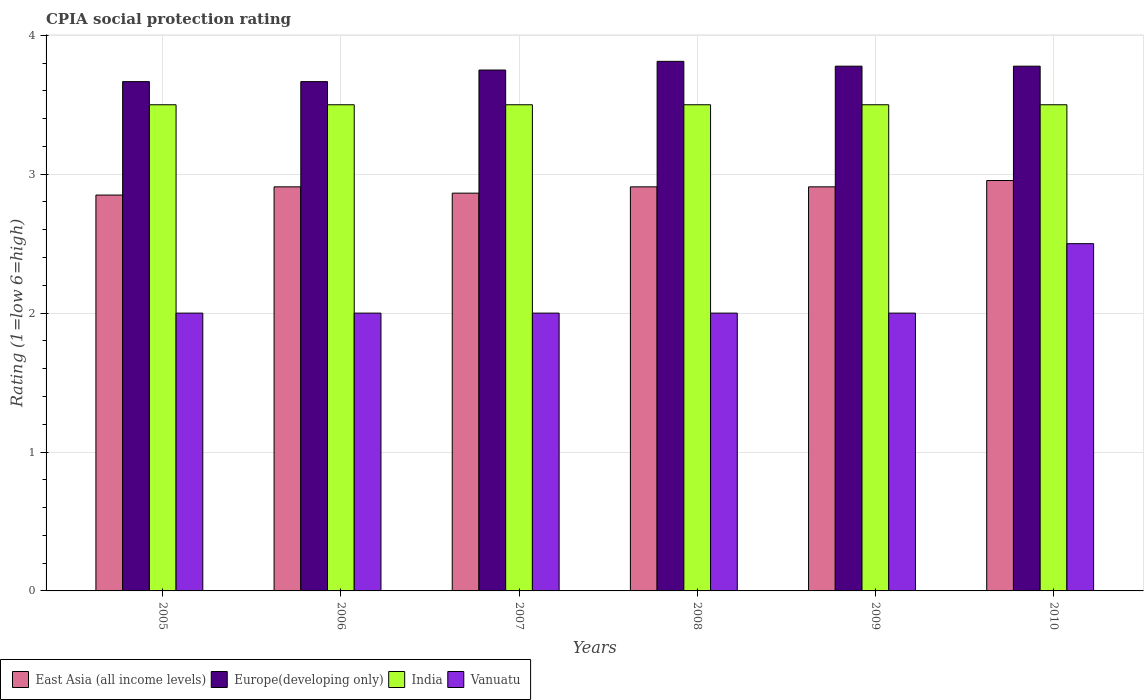How many different coloured bars are there?
Your response must be concise. 4. Are the number of bars per tick equal to the number of legend labels?
Offer a very short reply. Yes. How many bars are there on the 1st tick from the left?
Provide a short and direct response. 4. What is the label of the 2nd group of bars from the left?
Provide a succinct answer. 2006. In how many cases, is the number of bars for a given year not equal to the number of legend labels?
Give a very brief answer. 0. What is the CPIA rating in Vanuatu in 2005?
Provide a succinct answer. 2. Across all years, what is the maximum CPIA rating in East Asia (all income levels)?
Your answer should be compact. 2.95. What is the total CPIA rating in East Asia (all income levels) in the graph?
Offer a very short reply. 17.4. What is the difference between the CPIA rating in Europe(developing only) in 2008 and the CPIA rating in Vanuatu in 2010?
Your answer should be very brief. 1.31. What is the average CPIA rating in Europe(developing only) per year?
Your answer should be compact. 3.74. In the year 2008, what is the difference between the CPIA rating in India and CPIA rating in Europe(developing only)?
Offer a very short reply. -0.31. What is the ratio of the CPIA rating in East Asia (all income levels) in 2006 to that in 2008?
Offer a very short reply. 1. Is the CPIA rating in East Asia (all income levels) in 2006 less than that in 2009?
Your answer should be compact. No. Is the difference between the CPIA rating in India in 2006 and 2010 greater than the difference between the CPIA rating in Europe(developing only) in 2006 and 2010?
Keep it short and to the point. Yes. What is the difference between the highest and the second highest CPIA rating in East Asia (all income levels)?
Give a very brief answer. 0.05. What is the difference between the highest and the lowest CPIA rating in India?
Your answer should be compact. 0. What does the 2nd bar from the left in 2009 represents?
Offer a very short reply. Europe(developing only). What does the 4th bar from the right in 2007 represents?
Your response must be concise. East Asia (all income levels). Is it the case that in every year, the sum of the CPIA rating in Europe(developing only) and CPIA rating in East Asia (all income levels) is greater than the CPIA rating in India?
Give a very brief answer. Yes. How many years are there in the graph?
Ensure brevity in your answer.  6. Does the graph contain any zero values?
Give a very brief answer. No. Where does the legend appear in the graph?
Provide a short and direct response. Bottom left. How many legend labels are there?
Give a very brief answer. 4. What is the title of the graph?
Ensure brevity in your answer.  CPIA social protection rating. What is the label or title of the X-axis?
Provide a succinct answer. Years. What is the label or title of the Y-axis?
Give a very brief answer. Rating (1=low 6=high). What is the Rating (1=low 6=high) of East Asia (all income levels) in 2005?
Offer a very short reply. 2.85. What is the Rating (1=low 6=high) in Europe(developing only) in 2005?
Provide a succinct answer. 3.67. What is the Rating (1=low 6=high) of East Asia (all income levels) in 2006?
Make the answer very short. 2.91. What is the Rating (1=low 6=high) of Europe(developing only) in 2006?
Offer a terse response. 3.67. What is the Rating (1=low 6=high) in India in 2006?
Your answer should be compact. 3.5. What is the Rating (1=low 6=high) of Vanuatu in 2006?
Offer a terse response. 2. What is the Rating (1=low 6=high) of East Asia (all income levels) in 2007?
Ensure brevity in your answer.  2.86. What is the Rating (1=low 6=high) of Europe(developing only) in 2007?
Provide a short and direct response. 3.75. What is the Rating (1=low 6=high) in India in 2007?
Your response must be concise. 3.5. What is the Rating (1=low 6=high) in East Asia (all income levels) in 2008?
Offer a terse response. 2.91. What is the Rating (1=low 6=high) of Europe(developing only) in 2008?
Keep it short and to the point. 3.81. What is the Rating (1=low 6=high) in East Asia (all income levels) in 2009?
Offer a very short reply. 2.91. What is the Rating (1=low 6=high) of Europe(developing only) in 2009?
Keep it short and to the point. 3.78. What is the Rating (1=low 6=high) of Vanuatu in 2009?
Ensure brevity in your answer.  2. What is the Rating (1=low 6=high) of East Asia (all income levels) in 2010?
Provide a short and direct response. 2.95. What is the Rating (1=low 6=high) of Europe(developing only) in 2010?
Keep it short and to the point. 3.78. What is the Rating (1=low 6=high) of India in 2010?
Make the answer very short. 3.5. What is the Rating (1=low 6=high) in Vanuatu in 2010?
Your answer should be very brief. 2.5. Across all years, what is the maximum Rating (1=low 6=high) in East Asia (all income levels)?
Keep it short and to the point. 2.95. Across all years, what is the maximum Rating (1=low 6=high) of Europe(developing only)?
Make the answer very short. 3.81. Across all years, what is the minimum Rating (1=low 6=high) of East Asia (all income levels)?
Your response must be concise. 2.85. Across all years, what is the minimum Rating (1=low 6=high) in Europe(developing only)?
Ensure brevity in your answer.  3.67. What is the total Rating (1=low 6=high) of East Asia (all income levels) in the graph?
Offer a very short reply. 17.4. What is the total Rating (1=low 6=high) in Europe(developing only) in the graph?
Provide a succinct answer. 22.45. What is the total Rating (1=low 6=high) of Vanuatu in the graph?
Your answer should be very brief. 12.5. What is the difference between the Rating (1=low 6=high) in East Asia (all income levels) in 2005 and that in 2006?
Provide a succinct answer. -0.06. What is the difference between the Rating (1=low 6=high) in India in 2005 and that in 2006?
Your answer should be very brief. 0. What is the difference between the Rating (1=low 6=high) in Vanuatu in 2005 and that in 2006?
Ensure brevity in your answer.  0. What is the difference between the Rating (1=low 6=high) in East Asia (all income levels) in 2005 and that in 2007?
Offer a terse response. -0.01. What is the difference between the Rating (1=low 6=high) in Europe(developing only) in 2005 and that in 2007?
Your answer should be compact. -0.08. What is the difference between the Rating (1=low 6=high) in India in 2005 and that in 2007?
Give a very brief answer. 0. What is the difference between the Rating (1=low 6=high) in Vanuatu in 2005 and that in 2007?
Offer a very short reply. 0. What is the difference between the Rating (1=low 6=high) in East Asia (all income levels) in 2005 and that in 2008?
Provide a short and direct response. -0.06. What is the difference between the Rating (1=low 6=high) of Europe(developing only) in 2005 and that in 2008?
Your answer should be very brief. -0.15. What is the difference between the Rating (1=low 6=high) of India in 2005 and that in 2008?
Make the answer very short. 0. What is the difference between the Rating (1=low 6=high) of East Asia (all income levels) in 2005 and that in 2009?
Keep it short and to the point. -0.06. What is the difference between the Rating (1=low 6=high) of Europe(developing only) in 2005 and that in 2009?
Provide a succinct answer. -0.11. What is the difference between the Rating (1=low 6=high) of India in 2005 and that in 2009?
Your answer should be very brief. 0. What is the difference between the Rating (1=low 6=high) of Vanuatu in 2005 and that in 2009?
Your answer should be compact. 0. What is the difference between the Rating (1=low 6=high) of East Asia (all income levels) in 2005 and that in 2010?
Ensure brevity in your answer.  -0.1. What is the difference between the Rating (1=low 6=high) in Europe(developing only) in 2005 and that in 2010?
Make the answer very short. -0.11. What is the difference between the Rating (1=low 6=high) of India in 2005 and that in 2010?
Your answer should be compact. 0. What is the difference between the Rating (1=low 6=high) in Vanuatu in 2005 and that in 2010?
Make the answer very short. -0.5. What is the difference between the Rating (1=low 6=high) in East Asia (all income levels) in 2006 and that in 2007?
Your answer should be very brief. 0.05. What is the difference between the Rating (1=low 6=high) of Europe(developing only) in 2006 and that in 2007?
Keep it short and to the point. -0.08. What is the difference between the Rating (1=low 6=high) of East Asia (all income levels) in 2006 and that in 2008?
Provide a short and direct response. 0. What is the difference between the Rating (1=low 6=high) of Europe(developing only) in 2006 and that in 2008?
Ensure brevity in your answer.  -0.15. What is the difference between the Rating (1=low 6=high) of Vanuatu in 2006 and that in 2008?
Make the answer very short. 0. What is the difference between the Rating (1=low 6=high) in Europe(developing only) in 2006 and that in 2009?
Your response must be concise. -0.11. What is the difference between the Rating (1=low 6=high) of India in 2006 and that in 2009?
Provide a succinct answer. 0. What is the difference between the Rating (1=low 6=high) of East Asia (all income levels) in 2006 and that in 2010?
Ensure brevity in your answer.  -0.05. What is the difference between the Rating (1=low 6=high) in Europe(developing only) in 2006 and that in 2010?
Your answer should be very brief. -0.11. What is the difference between the Rating (1=low 6=high) of Vanuatu in 2006 and that in 2010?
Make the answer very short. -0.5. What is the difference between the Rating (1=low 6=high) of East Asia (all income levels) in 2007 and that in 2008?
Provide a succinct answer. -0.05. What is the difference between the Rating (1=low 6=high) in Europe(developing only) in 2007 and that in 2008?
Your answer should be very brief. -0.06. What is the difference between the Rating (1=low 6=high) of India in 2007 and that in 2008?
Ensure brevity in your answer.  0. What is the difference between the Rating (1=low 6=high) of East Asia (all income levels) in 2007 and that in 2009?
Keep it short and to the point. -0.05. What is the difference between the Rating (1=low 6=high) in Europe(developing only) in 2007 and that in 2009?
Provide a succinct answer. -0.03. What is the difference between the Rating (1=low 6=high) of Vanuatu in 2007 and that in 2009?
Provide a short and direct response. 0. What is the difference between the Rating (1=low 6=high) in East Asia (all income levels) in 2007 and that in 2010?
Your response must be concise. -0.09. What is the difference between the Rating (1=low 6=high) of Europe(developing only) in 2007 and that in 2010?
Make the answer very short. -0.03. What is the difference between the Rating (1=low 6=high) in Vanuatu in 2007 and that in 2010?
Your answer should be compact. -0.5. What is the difference between the Rating (1=low 6=high) of East Asia (all income levels) in 2008 and that in 2009?
Offer a very short reply. 0. What is the difference between the Rating (1=low 6=high) in Europe(developing only) in 2008 and that in 2009?
Your response must be concise. 0.03. What is the difference between the Rating (1=low 6=high) of Vanuatu in 2008 and that in 2009?
Provide a short and direct response. 0. What is the difference between the Rating (1=low 6=high) of East Asia (all income levels) in 2008 and that in 2010?
Give a very brief answer. -0.05. What is the difference between the Rating (1=low 6=high) in Europe(developing only) in 2008 and that in 2010?
Your response must be concise. 0.03. What is the difference between the Rating (1=low 6=high) of India in 2008 and that in 2010?
Ensure brevity in your answer.  0. What is the difference between the Rating (1=low 6=high) of Vanuatu in 2008 and that in 2010?
Provide a succinct answer. -0.5. What is the difference between the Rating (1=low 6=high) of East Asia (all income levels) in 2009 and that in 2010?
Your answer should be compact. -0.05. What is the difference between the Rating (1=low 6=high) in Vanuatu in 2009 and that in 2010?
Give a very brief answer. -0.5. What is the difference between the Rating (1=low 6=high) of East Asia (all income levels) in 2005 and the Rating (1=low 6=high) of Europe(developing only) in 2006?
Give a very brief answer. -0.82. What is the difference between the Rating (1=low 6=high) of East Asia (all income levels) in 2005 and the Rating (1=low 6=high) of India in 2006?
Your answer should be compact. -0.65. What is the difference between the Rating (1=low 6=high) in India in 2005 and the Rating (1=low 6=high) in Vanuatu in 2006?
Provide a short and direct response. 1.5. What is the difference between the Rating (1=low 6=high) in East Asia (all income levels) in 2005 and the Rating (1=low 6=high) in India in 2007?
Your answer should be very brief. -0.65. What is the difference between the Rating (1=low 6=high) of East Asia (all income levels) in 2005 and the Rating (1=low 6=high) of Vanuatu in 2007?
Your answer should be compact. 0.85. What is the difference between the Rating (1=low 6=high) in Europe(developing only) in 2005 and the Rating (1=low 6=high) in Vanuatu in 2007?
Provide a succinct answer. 1.67. What is the difference between the Rating (1=low 6=high) of India in 2005 and the Rating (1=low 6=high) of Vanuatu in 2007?
Give a very brief answer. 1.5. What is the difference between the Rating (1=low 6=high) of East Asia (all income levels) in 2005 and the Rating (1=low 6=high) of Europe(developing only) in 2008?
Ensure brevity in your answer.  -0.96. What is the difference between the Rating (1=low 6=high) of East Asia (all income levels) in 2005 and the Rating (1=low 6=high) of India in 2008?
Offer a terse response. -0.65. What is the difference between the Rating (1=low 6=high) in East Asia (all income levels) in 2005 and the Rating (1=low 6=high) in Vanuatu in 2008?
Provide a succinct answer. 0.85. What is the difference between the Rating (1=low 6=high) in India in 2005 and the Rating (1=low 6=high) in Vanuatu in 2008?
Give a very brief answer. 1.5. What is the difference between the Rating (1=low 6=high) of East Asia (all income levels) in 2005 and the Rating (1=low 6=high) of Europe(developing only) in 2009?
Keep it short and to the point. -0.93. What is the difference between the Rating (1=low 6=high) of East Asia (all income levels) in 2005 and the Rating (1=low 6=high) of India in 2009?
Your answer should be very brief. -0.65. What is the difference between the Rating (1=low 6=high) in India in 2005 and the Rating (1=low 6=high) in Vanuatu in 2009?
Provide a short and direct response. 1.5. What is the difference between the Rating (1=low 6=high) of East Asia (all income levels) in 2005 and the Rating (1=low 6=high) of Europe(developing only) in 2010?
Your response must be concise. -0.93. What is the difference between the Rating (1=low 6=high) of East Asia (all income levels) in 2005 and the Rating (1=low 6=high) of India in 2010?
Provide a succinct answer. -0.65. What is the difference between the Rating (1=low 6=high) of East Asia (all income levels) in 2006 and the Rating (1=low 6=high) of Europe(developing only) in 2007?
Provide a succinct answer. -0.84. What is the difference between the Rating (1=low 6=high) of East Asia (all income levels) in 2006 and the Rating (1=low 6=high) of India in 2007?
Your answer should be compact. -0.59. What is the difference between the Rating (1=low 6=high) of Europe(developing only) in 2006 and the Rating (1=low 6=high) of India in 2007?
Your answer should be very brief. 0.17. What is the difference between the Rating (1=low 6=high) of Europe(developing only) in 2006 and the Rating (1=low 6=high) of Vanuatu in 2007?
Keep it short and to the point. 1.67. What is the difference between the Rating (1=low 6=high) in India in 2006 and the Rating (1=low 6=high) in Vanuatu in 2007?
Make the answer very short. 1.5. What is the difference between the Rating (1=low 6=high) of East Asia (all income levels) in 2006 and the Rating (1=low 6=high) of Europe(developing only) in 2008?
Ensure brevity in your answer.  -0.9. What is the difference between the Rating (1=low 6=high) in East Asia (all income levels) in 2006 and the Rating (1=low 6=high) in India in 2008?
Your response must be concise. -0.59. What is the difference between the Rating (1=low 6=high) of Europe(developing only) in 2006 and the Rating (1=low 6=high) of India in 2008?
Offer a terse response. 0.17. What is the difference between the Rating (1=low 6=high) in Europe(developing only) in 2006 and the Rating (1=low 6=high) in Vanuatu in 2008?
Keep it short and to the point. 1.67. What is the difference between the Rating (1=low 6=high) in India in 2006 and the Rating (1=low 6=high) in Vanuatu in 2008?
Offer a terse response. 1.5. What is the difference between the Rating (1=low 6=high) in East Asia (all income levels) in 2006 and the Rating (1=low 6=high) in Europe(developing only) in 2009?
Keep it short and to the point. -0.87. What is the difference between the Rating (1=low 6=high) in East Asia (all income levels) in 2006 and the Rating (1=low 6=high) in India in 2009?
Your response must be concise. -0.59. What is the difference between the Rating (1=low 6=high) of Europe(developing only) in 2006 and the Rating (1=low 6=high) of India in 2009?
Make the answer very short. 0.17. What is the difference between the Rating (1=low 6=high) of Europe(developing only) in 2006 and the Rating (1=low 6=high) of Vanuatu in 2009?
Your answer should be compact. 1.67. What is the difference between the Rating (1=low 6=high) of India in 2006 and the Rating (1=low 6=high) of Vanuatu in 2009?
Offer a very short reply. 1.5. What is the difference between the Rating (1=low 6=high) of East Asia (all income levels) in 2006 and the Rating (1=low 6=high) of Europe(developing only) in 2010?
Ensure brevity in your answer.  -0.87. What is the difference between the Rating (1=low 6=high) in East Asia (all income levels) in 2006 and the Rating (1=low 6=high) in India in 2010?
Provide a succinct answer. -0.59. What is the difference between the Rating (1=low 6=high) in East Asia (all income levels) in 2006 and the Rating (1=low 6=high) in Vanuatu in 2010?
Provide a short and direct response. 0.41. What is the difference between the Rating (1=low 6=high) in Europe(developing only) in 2006 and the Rating (1=low 6=high) in India in 2010?
Your response must be concise. 0.17. What is the difference between the Rating (1=low 6=high) of India in 2006 and the Rating (1=low 6=high) of Vanuatu in 2010?
Give a very brief answer. 1. What is the difference between the Rating (1=low 6=high) in East Asia (all income levels) in 2007 and the Rating (1=low 6=high) in Europe(developing only) in 2008?
Provide a succinct answer. -0.95. What is the difference between the Rating (1=low 6=high) in East Asia (all income levels) in 2007 and the Rating (1=low 6=high) in India in 2008?
Offer a very short reply. -0.64. What is the difference between the Rating (1=low 6=high) in East Asia (all income levels) in 2007 and the Rating (1=low 6=high) in Vanuatu in 2008?
Give a very brief answer. 0.86. What is the difference between the Rating (1=low 6=high) of Europe(developing only) in 2007 and the Rating (1=low 6=high) of India in 2008?
Provide a succinct answer. 0.25. What is the difference between the Rating (1=low 6=high) in Europe(developing only) in 2007 and the Rating (1=low 6=high) in Vanuatu in 2008?
Provide a succinct answer. 1.75. What is the difference between the Rating (1=low 6=high) in East Asia (all income levels) in 2007 and the Rating (1=low 6=high) in Europe(developing only) in 2009?
Offer a terse response. -0.91. What is the difference between the Rating (1=low 6=high) of East Asia (all income levels) in 2007 and the Rating (1=low 6=high) of India in 2009?
Provide a short and direct response. -0.64. What is the difference between the Rating (1=low 6=high) of East Asia (all income levels) in 2007 and the Rating (1=low 6=high) of Vanuatu in 2009?
Make the answer very short. 0.86. What is the difference between the Rating (1=low 6=high) in Europe(developing only) in 2007 and the Rating (1=low 6=high) in India in 2009?
Provide a short and direct response. 0.25. What is the difference between the Rating (1=low 6=high) of Europe(developing only) in 2007 and the Rating (1=low 6=high) of Vanuatu in 2009?
Make the answer very short. 1.75. What is the difference between the Rating (1=low 6=high) in East Asia (all income levels) in 2007 and the Rating (1=low 6=high) in Europe(developing only) in 2010?
Keep it short and to the point. -0.91. What is the difference between the Rating (1=low 6=high) of East Asia (all income levels) in 2007 and the Rating (1=low 6=high) of India in 2010?
Your response must be concise. -0.64. What is the difference between the Rating (1=low 6=high) in East Asia (all income levels) in 2007 and the Rating (1=low 6=high) in Vanuatu in 2010?
Offer a terse response. 0.36. What is the difference between the Rating (1=low 6=high) of India in 2007 and the Rating (1=low 6=high) of Vanuatu in 2010?
Provide a short and direct response. 1. What is the difference between the Rating (1=low 6=high) of East Asia (all income levels) in 2008 and the Rating (1=low 6=high) of Europe(developing only) in 2009?
Provide a short and direct response. -0.87. What is the difference between the Rating (1=low 6=high) of East Asia (all income levels) in 2008 and the Rating (1=low 6=high) of India in 2009?
Your response must be concise. -0.59. What is the difference between the Rating (1=low 6=high) in East Asia (all income levels) in 2008 and the Rating (1=low 6=high) in Vanuatu in 2009?
Your answer should be very brief. 0.91. What is the difference between the Rating (1=low 6=high) in Europe(developing only) in 2008 and the Rating (1=low 6=high) in India in 2009?
Keep it short and to the point. 0.31. What is the difference between the Rating (1=low 6=high) in Europe(developing only) in 2008 and the Rating (1=low 6=high) in Vanuatu in 2009?
Make the answer very short. 1.81. What is the difference between the Rating (1=low 6=high) of East Asia (all income levels) in 2008 and the Rating (1=low 6=high) of Europe(developing only) in 2010?
Make the answer very short. -0.87. What is the difference between the Rating (1=low 6=high) in East Asia (all income levels) in 2008 and the Rating (1=low 6=high) in India in 2010?
Provide a short and direct response. -0.59. What is the difference between the Rating (1=low 6=high) in East Asia (all income levels) in 2008 and the Rating (1=low 6=high) in Vanuatu in 2010?
Ensure brevity in your answer.  0.41. What is the difference between the Rating (1=low 6=high) in Europe(developing only) in 2008 and the Rating (1=low 6=high) in India in 2010?
Your response must be concise. 0.31. What is the difference between the Rating (1=low 6=high) in Europe(developing only) in 2008 and the Rating (1=low 6=high) in Vanuatu in 2010?
Provide a succinct answer. 1.31. What is the difference between the Rating (1=low 6=high) of East Asia (all income levels) in 2009 and the Rating (1=low 6=high) of Europe(developing only) in 2010?
Provide a short and direct response. -0.87. What is the difference between the Rating (1=low 6=high) of East Asia (all income levels) in 2009 and the Rating (1=low 6=high) of India in 2010?
Your answer should be compact. -0.59. What is the difference between the Rating (1=low 6=high) in East Asia (all income levels) in 2009 and the Rating (1=low 6=high) in Vanuatu in 2010?
Your answer should be compact. 0.41. What is the difference between the Rating (1=low 6=high) of Europe(developing only) in 2009 and the Rating (1=low 6=high) of India in 2010?
Keep it short and to the point. 0.28. What is the difference between the Rating (1=low 6=high) in Europe(developing only) in 2009 and the Rating (1=low 6=high) in Vanuatu in 2010?
Your answer should be compact. 1.28. What is the average Rating (1=low 6=high) in East Asia (all income levels) per year?
Provide a short and direct response. 2.9. What is the average Rating (1=low 6=high) of Europe(developing only) per year?
Provide a short and direct response. 3.74. What is the average Rating (1=low 6=high) of India per year?
Offer a terse response. 3.5. What is the average Rating (1=low 6=high) in Vanuatu per year?
Make the answer very short. 2.08. In the year 2005, what is the difference between the Rating (1=low 6=high) in East Asia (all income levels) and Rating (1=low 6=high) in Europe(developing only)?
Provide a succinct answer. -0.82. In the year 2005, what is the difference between the Rating (1=low 6=high) of East Asia (all income levels) and Rating (1=low 6=high) of India?
Make the answer very short. -0.65. In the year 2005, what is the difference between the Rating (1=low 6=high) of East Asia (all income levels) and Rating (1=low 6=high) of Vanuatu?
Your answer should be very brief. 0.85. In the year 2006, what is the difference between the Rating (1=low 6=high) in East Asia (all income levels) and Rating (1=low 6=high) in Europe(developing only)?
Your answer should be very brief. -0.76. In the year 2006, what is the difference between the Rating (1=low 6=high) of East Asia (all income levels) and Rating (1=low 6=high) of India?
Provide a succinct answer. -0.59. In the year 2006, what is the difference between the Rating (1=low 6=high) of Europe(developing only) and Rating (1=low 6=high) of Vanuatu?
Make the answer very short. 1.67. In the year 2006, what is the difference between the Rating (1=low 6=high) in India and Rating (1=low 6=high) in Vanuatu?
Offer a very short reply. 1.5. In the year 2007, what is the difference between the Rating (1=low 6=high) of East Asia (all income levels) and Rating (1=low 6=high) of Europe(developing only)?
Provide a succinct answer. -0.89. In the year 2007, what is the difference between the Rating (1=low 6=high) in East Asia (all income levels) and Rating (1=low 6=high) in India?
Provide a short and direct response. -0.64. In the year 2007, what is the difference between the Rating (1=low 6=high) of East Asia (all income levels) and Rating (1=low 6=high) of Vanuatu?
Keep it short and to the point. 0.86. In the year 2008, what is the difference between the Rating (1=low 6=high) of East Asia (all income levels) and Rating (1=low 6=high) of Europe(developing only)?
Your answer should be very brief. -0.9. In the year 2008, what is the difference between the Rating (1=low 6=high) of East Asia (all income levels) and Rating (1=low 6=high) of India?
Your answer should be compact. -0.59. In the year 2008, what is the difference between the Rating (1=low 6=high) in Europe(developing only) and Rating (1=low 6=high) in India?
Provide a succinct answer. 0.31. In the year 2008, what is the difference between the Rating (1=low 6=high) in Europe(developing only) and Rating (1=low 6=high) in Vanuatu?
Your answer should be very brief. 1.81. In the year 2008, what is the difference between the Rating (1=low 6=high) in India and Rating (1=low 6=high) in Vanuatu?
Provide a short and direct response. 1.5. In the year 2009, what is the difference between the Rating (1=low 6=high) in East Asia (all income levels) and Rating (1=low 6=high) in Europe(developing only)?
Provide a succinct answer. -0.87. In the year 2009, what is the difference between the Rating (1=low 6=high) in East Asia (all income levels) and Rating (1=low 6=high) in India?
Keep it short and to the point. -0.59. In the year 2009, what is the difference between the Rating (1=low 6=high) of Europe(developing only) and Rating (1=low 6=high) of India?
Ensure brevity in your answer.  0.28. In the year 2009, what is the difference between the Rating (1=low 6=high) in Europe(developing only) and Rating (1=low 6=high) in Vanuatu?
Offer a terse response. 1.78. In the year 2010, what is the difference between the Rating (1=low 6=high) in East Asia (all income levels) and Rating (1=low 6=high) in Europe(developing only)?
Provide a succinct answer. -0.82. In the year 2010, what is the difference between the Rating (1=low 6=high) of East Asia (all income levels) and Rating (1=low 6=high) of India?
Ensure brevity in your answer.  -0.55. In the year 2010, what is the difference between the Rating (1=low 6=high) of East Asia (all income levels) and Rating (1=low 6=high) of Vanuatu?
Your answer should be very brief. 0.45. In the year 2010, what is the difference between the Rating (1=low 6=high) of Europe(developing only) and Rating (1=low 6=high) of India?
Make the answer very short. 0.28. In the year 2010, what is the difference between the Rating (1=low 6=high) of Europe(developing only) and Rating (1=low 6=high) of Vanuatu?
Your answer should be very brief. 1.28. In the year 2010, what is the difference between the Rating (1=low 6=high) in India and Rating (1=low 6=high) in Vanuatu?
Your response must be concise. 1. What is the ratio of the Rating (1=low 6=high) of East Asia (all income levels) in 2005 to that in 2006?
Your answer should be compact. 0.98. What is the ratio of the Rating (1=low 6=high) in Europe(developing only) in 2005 to that in 2007?
Give a very brief answer. 0.98. What is the ratio of the Rating (1=low 6=high) in India in 2005 to that in 2007?
Make the answer very short. 1. What is the ratio of the Rating (1=low 6=high) in East Asia (all income levels) in 2005 to that in 2008?
Ensure brevity in your answer.  0.98. What is the ratio of the Rating (1=low 6=high) in Europe(developing only) in 2005 to that in 2008?
Your answer should be very brief. 0.96. What is the ratio of the Rating (1=low 6=high) of East Asia (all income levels) in 2005 to that in 2009?
Make the answer very short. 0.98. What is the ratio of the Rating (1=low 6=high) in Europe(developing only) in 2005 to that in 2009?
Keep it short and to the point. 0.97. What is the ratio of the Rating (1=low 6=high) in Vanuatu in 2005 to that in 2009?
Give a very brief answer. 1. What is the ratio of the Rating (1=low 6=high) in East Asia (all income levels) in 2005 to that in 2010?
Offer a very short reply. 0.96. What is the ratio of the Rating (1=low 6=high) in Europe(developing only) in 2005 to that in 2010?
Your answer should be compact. 0.97. What is the ratio of the Rating (1=low 6=high) in India in 2005 to that in 2010?
Offer a very short reply. 1. What is the ratio of the Rating (1=low 6=high) in Vanuatu in 2005 to that in 2010?
Your answer should be compact. 0.8. What is the ratio of the Rating (1=low 6=high) of East Asia (all income levels) in 2006 to that in 2007?
Your answer should be compact. 1.02. What is the ratio of the Rating (1=low 6=high) of Europe(developing only) in 2006 to that in 2007?
Provide a succinct answer. 0.98. What is the ratio of the Rating (1=low 6=high) of India in 2006 to that in 2007?
Give a very brief answer. 1. What is the ratio of the Rating (1=low 6=high) of Vanuatu in 2006 to that in 2007?
Your response must be concise. 1. What is the ratio of the Rating (1=low 6=high) of Europe(developing only) in 2006 to that in 2008?
Provide a succinct answer. 0.96. What is the ratio of the Rating (1=low 6=high) in Europe(developing only) in 2006 to that in 2009?
Your response must be concise. 0.97. What is the ratio of the Rating (1=low 6=high) of East Asia (all income levels) in 2006 to that in 2010?
Ensure brevity in your answer.  0.98. What is the ratio of the Rating (1=low 6=high) in Europe(developing only) in 2006 to that in 2010?
Your answer should be very brief. 0.97. What is the ratio of the Rating (1=low 6=high) of East Asia (all income levels) in 2007 to that in 2008?
Make the answer very short. 0.98. What is the ratio of the Rating (1=low 6=high) in Europe(developing only) in 2007 to that in 2008?
Your answer should be very brief. 0.98. What is the ratio of the Rating (1=low 6=high) in India in 2007 to that in 2008?
Ensure brevity in your answer.  1. What is the ratio of the Rating (1=low 6=high) of East Asia (all income levels) in 2007 to that in 2009?
Give a very brief answer. 0.98. What is the ratio of the Rating (1=low 6=high) of Europe(developing only) in 2007 to that in 2009?
Provide a short and direct response. 0.99. What is the ratio of the Rating (1=low 6=high) in India in 2007 to that in 2009?
Offer a very short reply. 1. What is the ratio of the Rating (1=low 6=high) in Vanuatu in 2007 to that in 2009?
Ensure brevity in your answer.  1. What is the ratio of the Rating (1=low 6=high) in East Asia (all income levels) in 2007 to that in 2010?
Offer a very short reply. 0.97. What is the ratio of the Rating (1=low 6=high) of Vanuatu in 2007 to that in 2010?
Your response must be concise. 0.8. What is the ratio of the Rating (1=low 6=high) in Europe(developing only) in 2008 to that in 2009?
Ensure brevity in your answer.  1.01. What is the ratio of the Rating (1=low 6=high) in Vanuatu in 2008 to that in 2009?
Offer a terse response. 1. What is the ratio of the Rating (1=low 6=high) in East Asia (all income levels) in 2008 to that in 2010?
Make the answer very short. 0.98. What is the ratio of the Rating (1=low 6=high) of Europe(developing only) in 2008 to that in 2010?
Offer a very short reply. 1.01. What is the ratio of the Rating (1=low 6=high) in Vanuatu in 2008 to that in 2010?
Provide a short and direct response. 0.8. What is the ratio of the Rating (1=low 6=high) in East Asia (all income levels) in 2009 to that in 2010?
Make the answer very short. 0.98. What is the ratio of the Rating (1=low 6=high) of India in 2009 to that in 2010?
Give a very brief answer. 1. What is the ratio of the Rating (1=low 6=high) of Vanuatu in 2009 to that in 2010?
Your answer should be very brief. 0.8. What is the difference between the highest and the second highest Rating (1=low 6=high) of East Asia (all income levels)?
Provide a succinct answer. 0.05. What is the difference between the highest and the second highest Rating (1=low 6=high) of Europe(developing only)?
Your answer should be very brief. 0.03. What is the difference between the highest and the second highest Rating (1=low 6=high) in Vanuatu?
Your answer should be very brief. 0.5. What is the difference between the highest and the lowest Rating (1=low 6=high) of East Asia (all income levels)?
Provide a short and direct response. 0.1. What is the difference between the highest and the lowest Rating (1=low 6=high) of Europe(developing only)?
Make the answer very short. 0.15. 